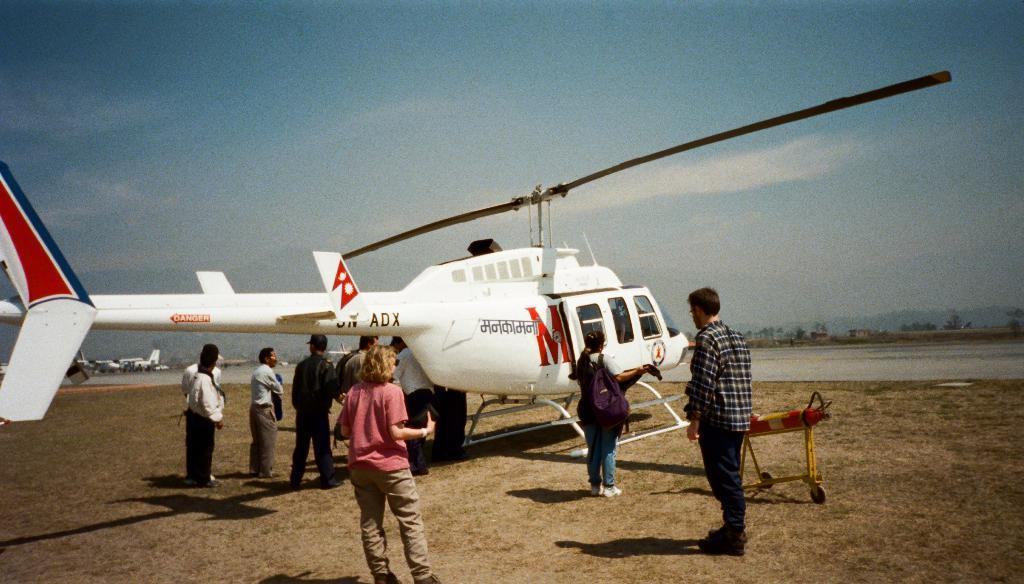<image>
Relay a brief, clear account of the picture shown. A helicopter with a  large letter M near the door. 